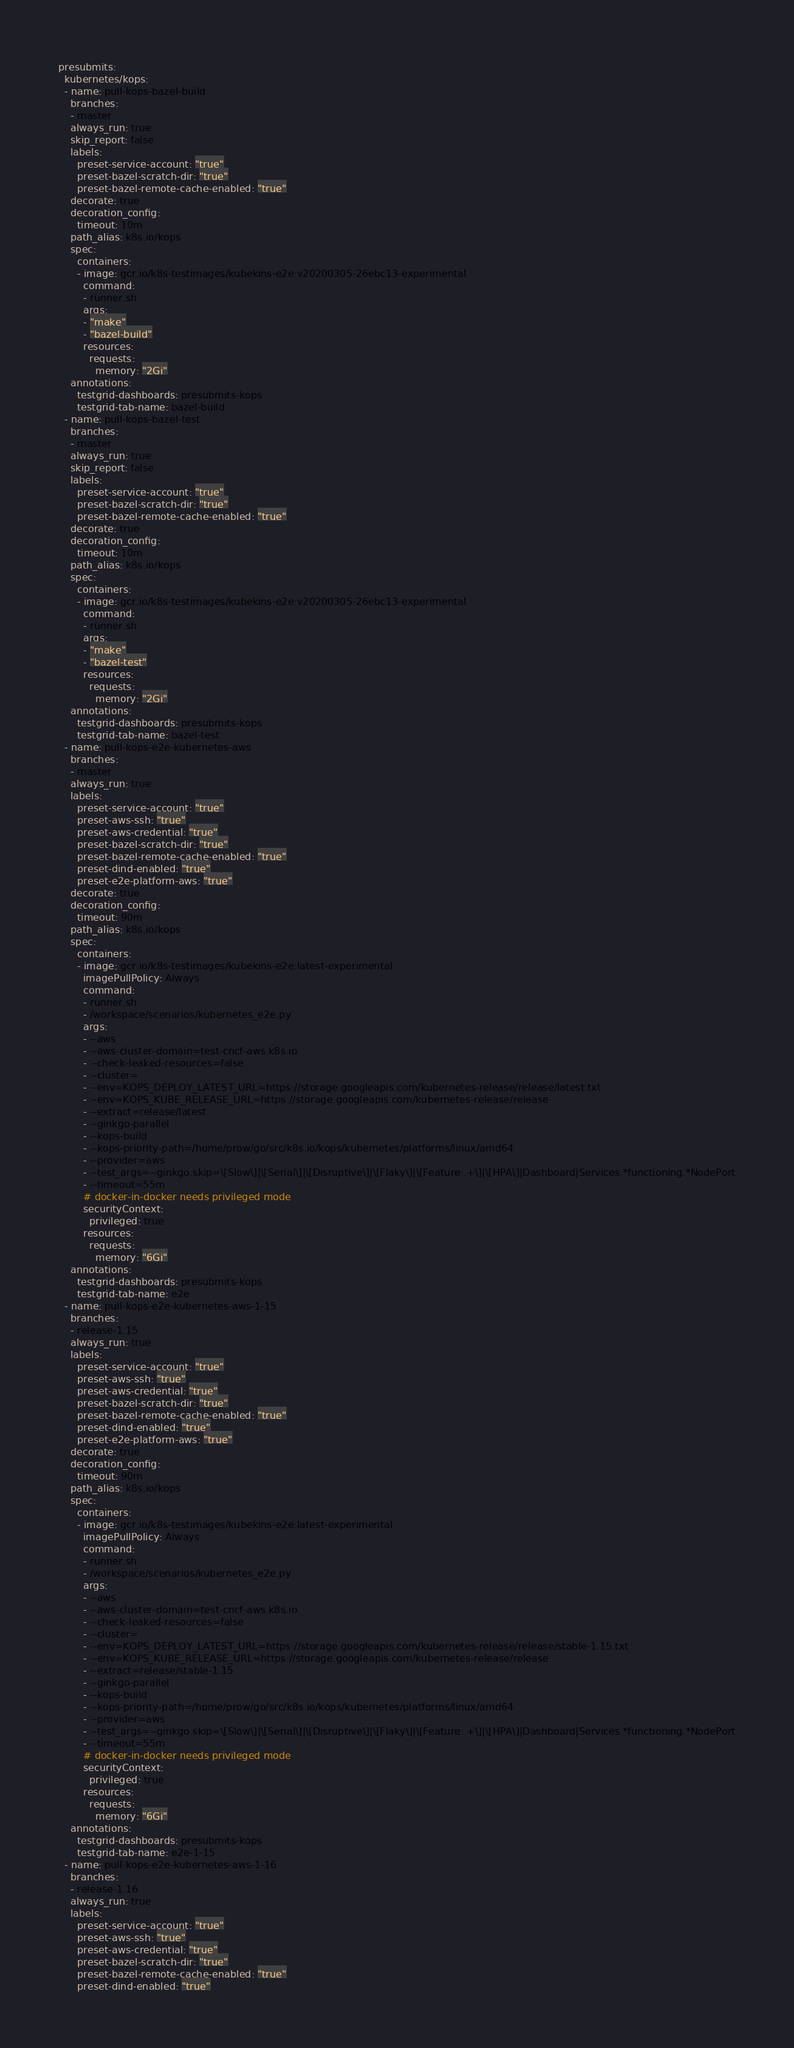<code> <loc_0><loc_0><loc_500><loc_500><_YAML_>presubmits:
  kubernetes/kops:
  - name: pull-kops-bazel-build
    branches:
    - master
    always_run: true
    skip_report: false
    labels:
      preset-service-account: "true"
      preset-bazel-scratch-dir: "true"
      preset-bazel-remote-cache-enabled: "true"
    decorate: true
    decoration_config:
      timeout: 10m
    path_alias: k8s.io/kops
    spec:
      containers:
      - image: gcr.io/k8s-testimages/kubekins-e2e:v20200305-26ebc13-experimental
        command:
        - runner.sh
        args:
        - "make"
        - "bazel-build"
        resources:
          requests:
            memory: "2Gi"
    annotations:
      testgrid-dashboards: presubmits-kops
      testgrid-tab-name: bazel-build
  - name: pull-kops-bazel-test
    branches:
    - master
    always_run: true
    skip_report: false
    labels:
      preset-service-account: "true"
      preset-bazel-scratch-dir: "true"
      preset-bazel-remote-cache-enabled: "true"
    decorate: true
    decoration_config:
      timeout: 10m
    path_alias: k8s.io/kops
    spec:
      containers:
      - image: gcr.io/k8s-testimages/kubekins-e2e:v20200305-26ebc13-experimental
        command:
        - runner.sh
        args:
        - "make"
        - "bazel-test"
        resources:
          requests:
            memory: "2Gi"
    annotations:
      testgrid-dashboards: presubmits-kops
      testgrid-tab-name: bazel-test
  - name: pull-kops-e2e-kubernetes-aws
    branches:
    - master
    always_run: true
    labels:
      preset-service-account: "true"
      preset-aws-ssh: "true"
      preset-aws-credential: "true"
      preset-bazel-scratch-dir: "true"
      preset-bazel-remote-cache-enabled: "true"
      preset-dind-enabled: "true"
      preset-e2e-platform-aws: "true"
    decorate: true
    decoration_config:
      timeout: 90m
    path_alias: k8s.io/kops
    spec:
      containers:
      - image: gcr.io/k8s-testimages/kubekins-e2e:latest-experimental
        imagePullPolicy: Always
        command:
        - runner.sh
        - /workspace/scenarios/kubernetes_e2e.py
        args:
        - --aws
        - --aws-cluster-domain=test-cncf-aws.k8s.io
        - --check-leaked-resources=false
        - --cluster=
        - --env=KOPS_DEPLOY_LATEST_URL=https://storage.googleapis.com/kubernetes-release/release/latest.txt
        - --env=KOPS_KUBE_RELEASE_URL=https://storage.googleapis.com/kubernetes-release/release
        - --extract=release/latest
        - --ginkgo-parallel
        - --kops-build
        - --kops-priority-path=/home/prow/go/src/k8s.io/kops/kubernetes/platforms/linux/amd64
        - --provider=aws
        - --test_args=--ginkgo.skip=\[Slow\]|\[Serial\]|\[Disruptive\]|\[Flaky\]|\[Feature:.+\]|\[HPA\]|Dashboard|Services.*functioning.*NodePort
        - --timeout=55m
        # docker-in-docker needs privileged mode
        securityContext:
          privileged: true
        resources:
          requests:
            memory: "6Gi"
    annotations:
      testgrid-dashboards: presubmits-kops
      testgrid-tab-name: e2e
  - name: pull-kops-e2e-kubernetes-aws-1-15
    branches:
    - release-1.15
    always_run: true
    labels:
      preset-service-account: "true"
      preset-aws-ssh: "true"
      preset-aws-credential: "true"
      preset-bazel-scratch-dir: "true"
      preset-bazel-remote-cache-enabled: "true"
      preset-dind-enabled: "true"
      preset-e2e-platform-aws: "true"
    decorate: true
    decoration_config:
      timeout: 90m
    path_alias: k8s.io/kops
    spec:
      containers:
      - image: gcr.io/k8s-testimages/kubekins-e2e:latest-experimental
        imagePullPolicy: Always
        command:
        - runner.sh
        - /workspace/scenarios/kubernetes_e2e.py
        args:
        - --aws
        - --aws-cluster-domain=test-cncf-aws.k8s.io
        - --check-leaked-resources=false
        - --cluster=
        - --env=KOPS_DEPLOY_LATEST_URL=https://storage.googleapis.com/kubernetes-release/release/stable-1.15.txt
        - --env=KOPS_KUBE_RELEASE_URL=https://storage.googleapis.com/kubernetes-release/release
        - --extract=release/stable-1.15
        - --ginkgo-parallel
        - --kops-build
        - --kops-priority-path=/home/prow/go/src/k8s.io/kops/kubernetes/platforms/linux/amd64
        - --provider=aws
        - --test_args=--ginkgo.skip=\[Slow\]|\[Serial\]|\[Disruptive\]|\[Flaky\]|\[Feature:.+\]|\[HPA\]|Dashboard|Services.*functioning.*NodePort
        - --timeout=55m
        # docker-in-docker needs privileged mode
        securityContext:
          privileged: true
        resources:
          requests:
            memory: "6Gi"
    annotations:
      testgrid-dashboards: presubmits-kops
      testgrid-tab-name: e2e-1-15
  - name: pull-kops-e2e-kubernetes-aws-1-16
    branches:
    - release-1.16
    always_run: true
    labels:
      preset-service-account: "true"
      preset-aws-ssh: "true"
      preset-aws-credential: "true"
      preset-bazel-scratch-dir: "true"
      preset-bazel-remote-cache-enabled: "true"
      preset-dind-enabled: "true"</code> 